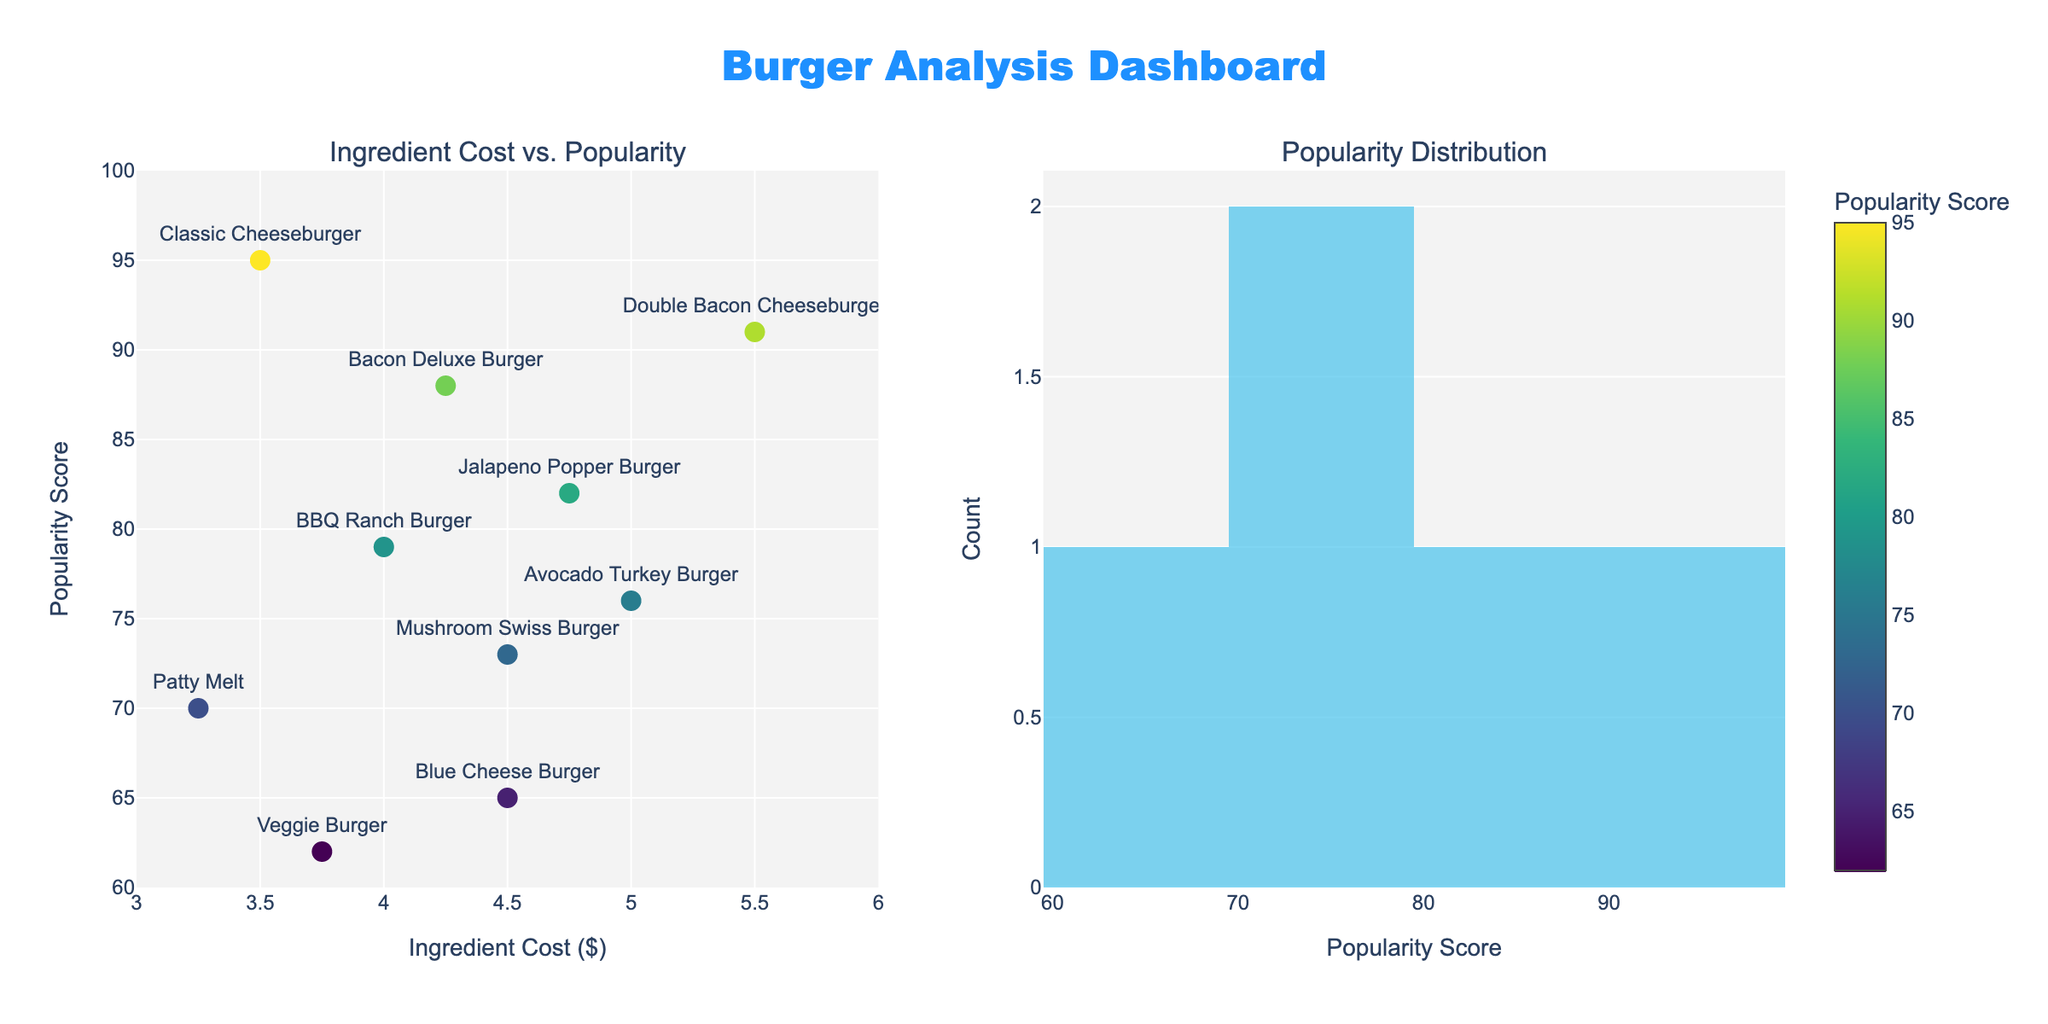What is the title of this dashboard? The title is usually located at the top of the figure. Here, it is placed centrally and reads "Burger Analysis Dashboard".
Answer: Burger Analysis Dashboard What axis title indicates ingredient cost? By looking at the first subplot (scatter plot), the x-axis is labeled as “Ingredient Cost ($)”.
Answer: Ingredient Cost ($) How many dishes are included in the scatter plot? Count the number of data points (markers) in the scatter plot. There are 10 markers, corresponding to 10 different dishes.
Answer: 10 Which burger has the highest ingredient cost? Identify the point farthest to the right on the x-axis within the scatter plot. The "Double Bacon Cheeseburger" is at $5.50.
Answer: Double Bacon Cheeseburger Which burger has the highest popularity score? Identify the point highest on the y-axis within the scatter plot. The "Classic Cheeseburger" has a popularity score of 95.
Answer: Classic Cheeseburger What is the popularity score of the BBQ Ranch Burger? Find the point labeled "BBQ Ranch Burger" in the scatter plot and check its y-value, which is 79.
Answer: 79 Which two burgers have the same ingredient cost and what is that cost? Locate the points with the same x-value in the scatter plot. "Mushroom Swiss Burger" and "Blue Cheese Burger" both have an ingredient cost of $4.50.
Answer: Mushroom Swiss Burger, Blue Cheese Burger, $4.50 What is the average ingredient cost of all burgers? Sum the ingredient costs of all burgers and divide by the number of burgers (10). Calculation: (3.50 + 4.25 + 3.75 + 4.00 + 4.50 + 3.25 + 4.75 + 4.50 + 5.00 + 5.50) / 10 = 43.00 / 10 = $4.30
Answer: $4.30 How many burgers have a popularity score of 80 or higher? Refer to the histogram in the second subplot and count the bins from 80 to 100. The histogram shows there are 5 burgers in this range.
Answer: 5 Do more burgers fall into the popularity score range of 60-70 or 70-80? Refer to the histogram and compare the bins corresponding to 60-70 and 70-80. There are 2 burgers in 60-70 and 3 in 70-80.
Answer: 70-80 